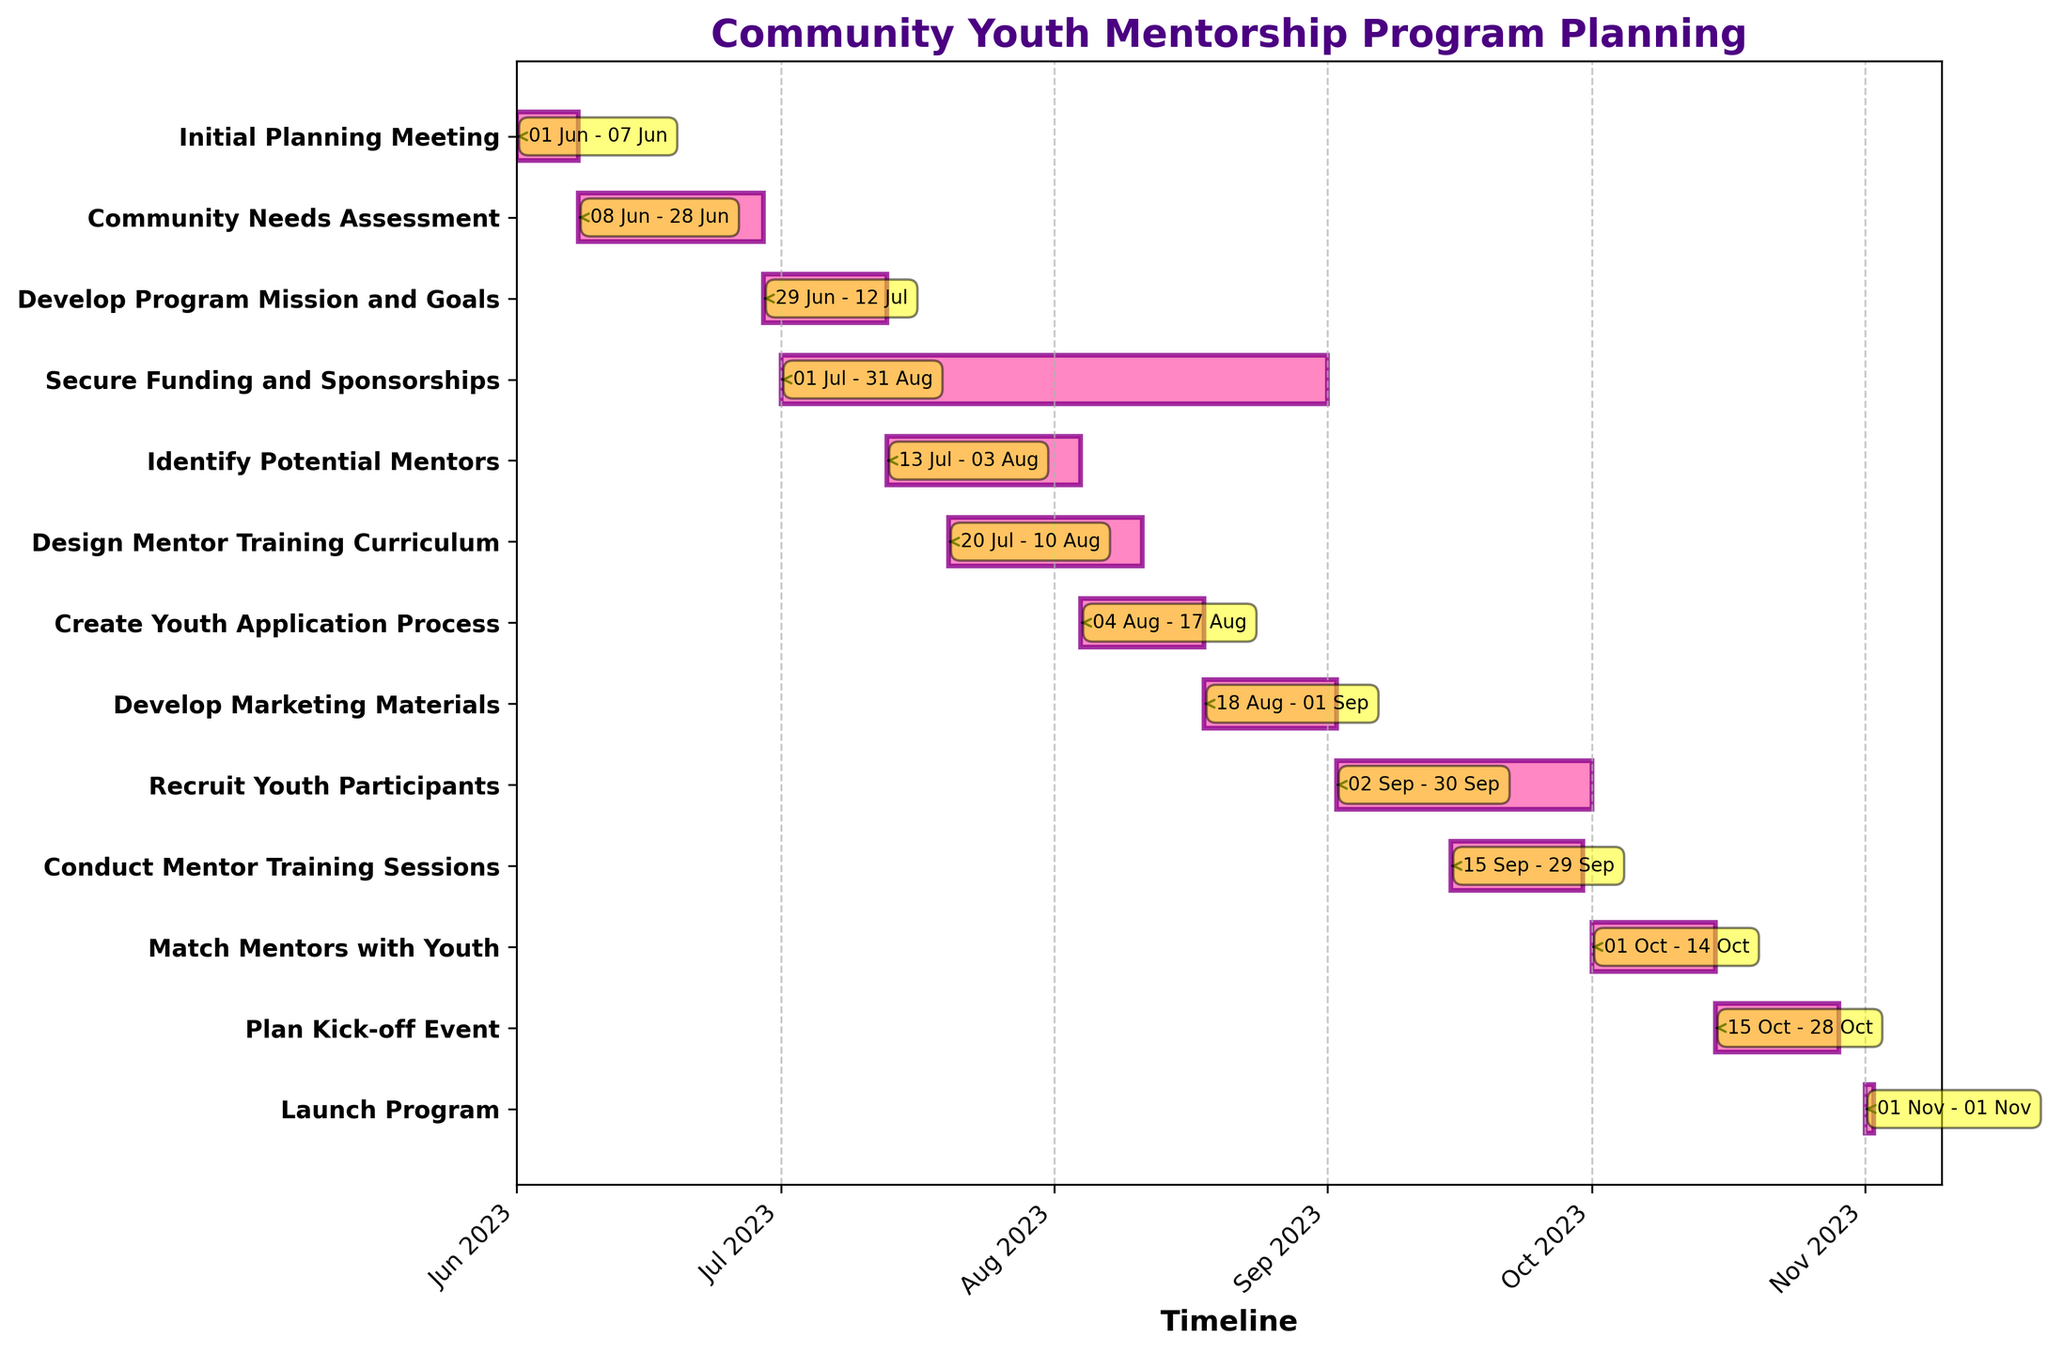What is the title of the Gantt chart? The title is prominently displayed at the top of the chart. It is meant to provide a summary of the chart's content.
Answer: Community Youth Mentorship Program Planning What is the duration in days of the "Initial Planning Meeting"? Locate the "Initial Planning Meeting" task on the y-axis and check the length of the corresponding horizontal bar. The label at the end shows the duration.
Answer: 7 days Which task has the longest duration, and what is it? Compare the lengths of all the horizontal bars to find the longest one. The task with the longest bar is the one with the longest duration.
Answer: Secure Funding and Sponsorships with 62 days When does the "Match Mentors with Youth" task start and end? Find the "Match Mentors with Youth" on the y-axis and look at the start and end dates labeled on the bar.
Answer: Starts on 2023-10-01 and ends on 2023-10-14 Which two tasks take place entirely in July? Identify tasks that both start and end within the month of July by examining the start and end dates of each bar.
Answer: Develop Program Mission and Goals, Secure Funding and Sponsorships How many tasks start in August? Review each task's start date and count those that begin within August.
Answer: Four tasks What is the total duration for "Recruit Youth Participants" and "Conduct Mentor Training Sessions" combined? Sum the durations of the "Recruit Youth Participants" and "Conduct Mentor Training Sessions" tasks by referring to their duration labels.
Answer: 44 days (29 days + 15 days) Which tasks overlap with "Design Mentor Training Curriculum"? Find tasks that start before "Design Mentor Training Curriculum" ends and end after it starts by comparing their dates.
Answer: Identify Potential Mentors, Secure Funding and Sponsorships What is the end date for the "Develop Marketing Materials" task? Locate the end date label on the "Develop Marketing Materials" bar.
Answer: 2023-09-01 Between which months does the "Secure Funding and Sponsorships" task span? Note the start and end months for "Secure Funding and Sponsorships" by examining its start and end dates.
Answer: July and August 